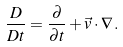<formula> <loc_0><loc_0><loc_500><loc_500>\frac { D } { D t } = \frac { \partial } { \partial t } + \vec { v } \cdot \nabla \, .</formula> 